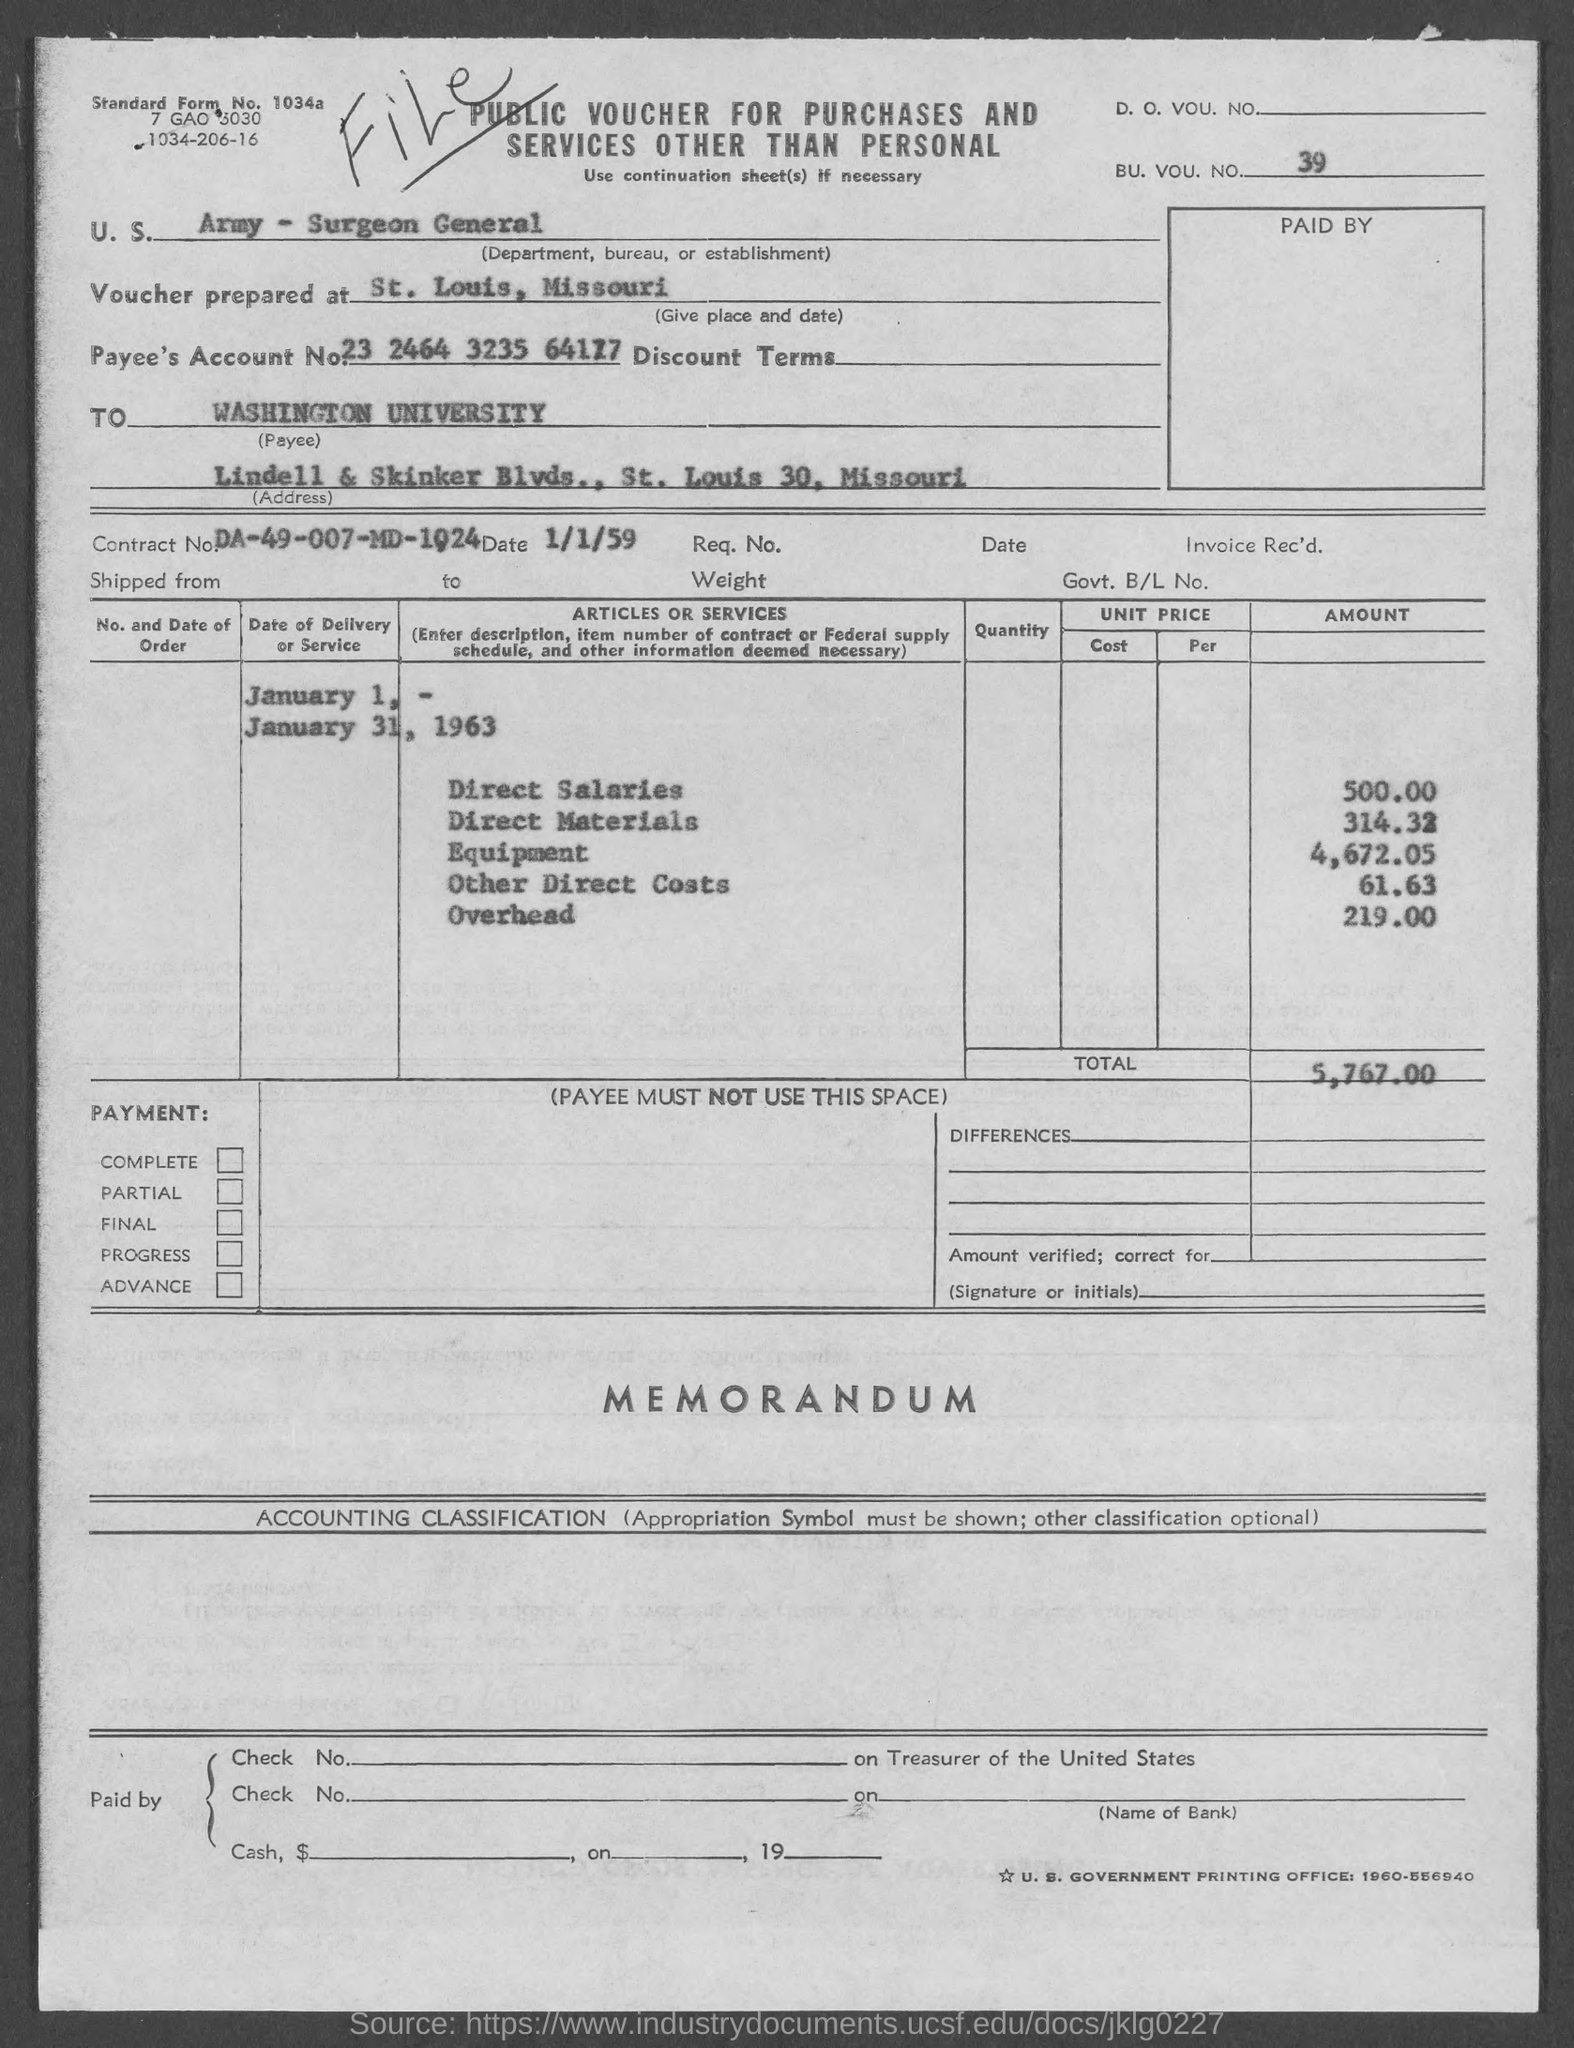What is the document title?
Make the answer very short. Public voucher for purchases and services other than personal. What is the BU. VOU. NO.?
Provide a succinct answer. 39. Which is the department mentioned?
Your answer should be compact. Army - Surgeon General. What is Payee's Account No.?
Provide a succinct answer. 23 2464 3235 64177. Where was the voucher prepared?
Offer a terse response. At st. louis, missouri. What is the total amount specified?
Keep it short and to the point. 5,767.00. 